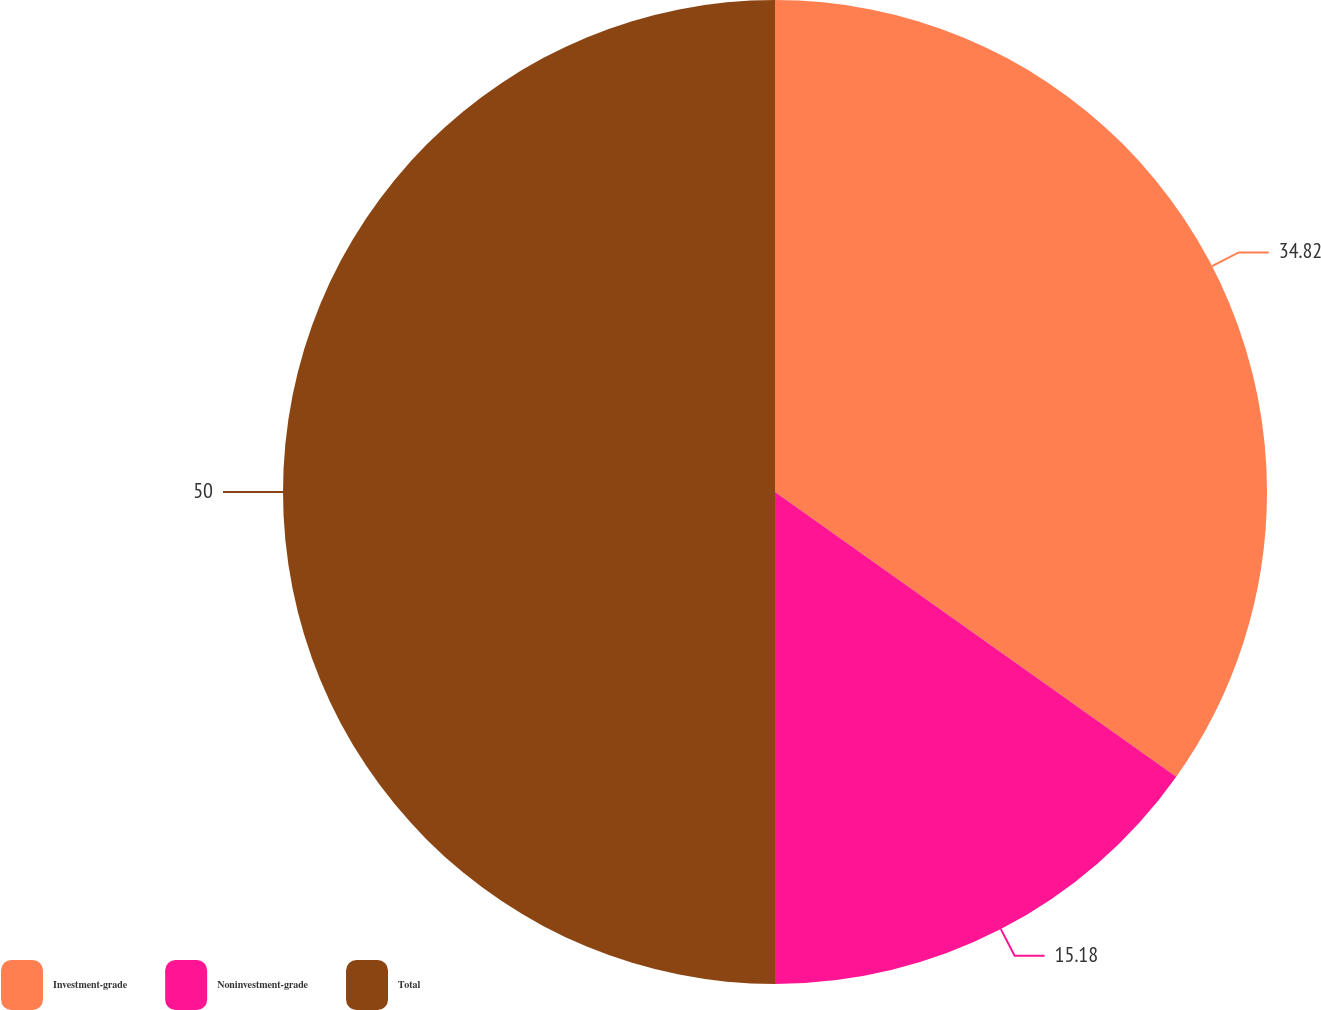Convert chart to OTSL. <chart><loc_0><loc_0><loc_500><loc_500><pie_chart><fcel>Investment-grade<fcel>Noninvestment-grade<fcel>Total<nl><fcel>34.82%<fcel>15.18%<fcel>50.0%<nl></chart> 